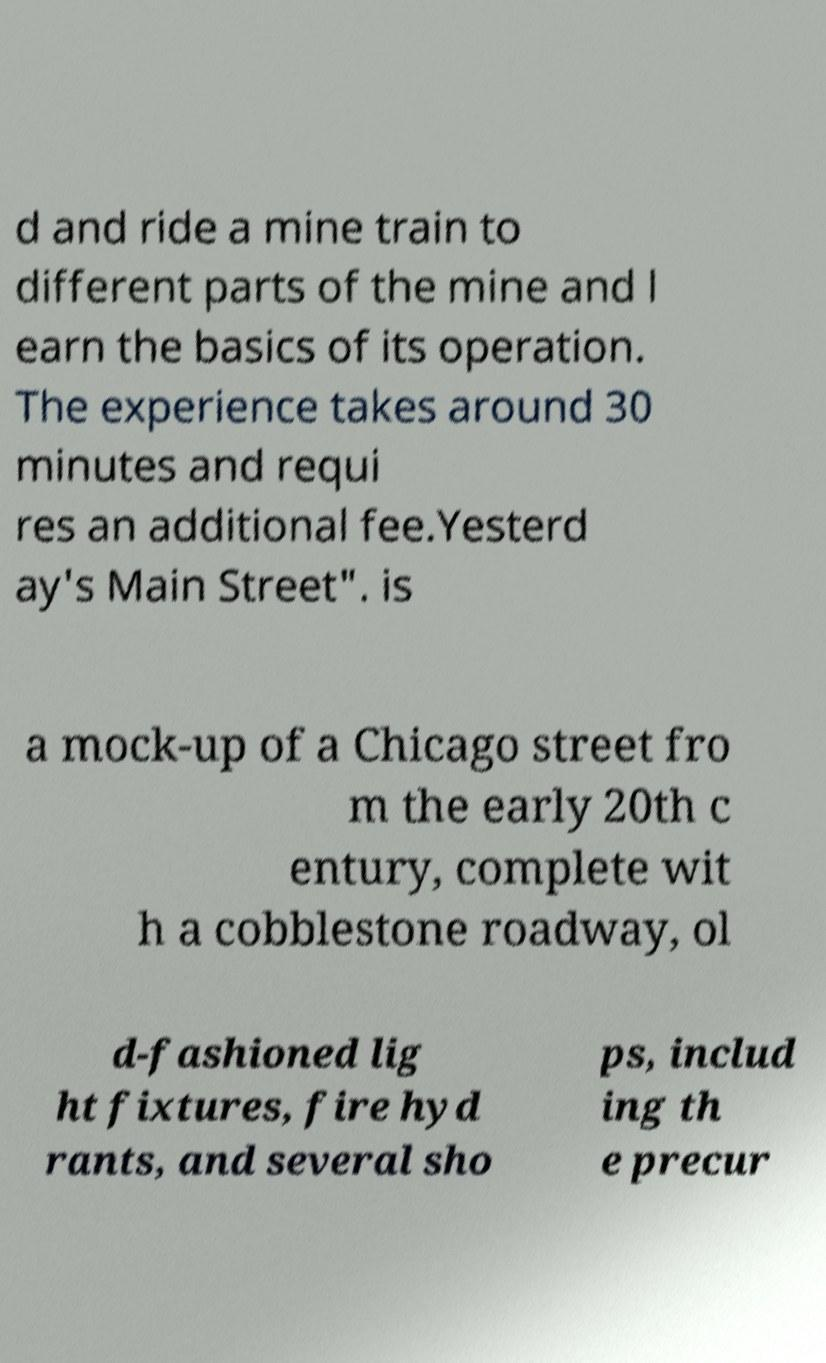Could you extract and type out the text from this image? d and ride a mine train to different parts of the mine and l earn the basics of its operation. The experience takes around 30 minutes and requi res an additional fee.Yesterd ay's Main Street". is a mock-up of a Chicago street fro m the early 20th c entury, complete wit h a cobblestone roadway, ol d-fashioned lig ht fixtures, fire hyd rants, and several sho ps, includ ing th e precur 